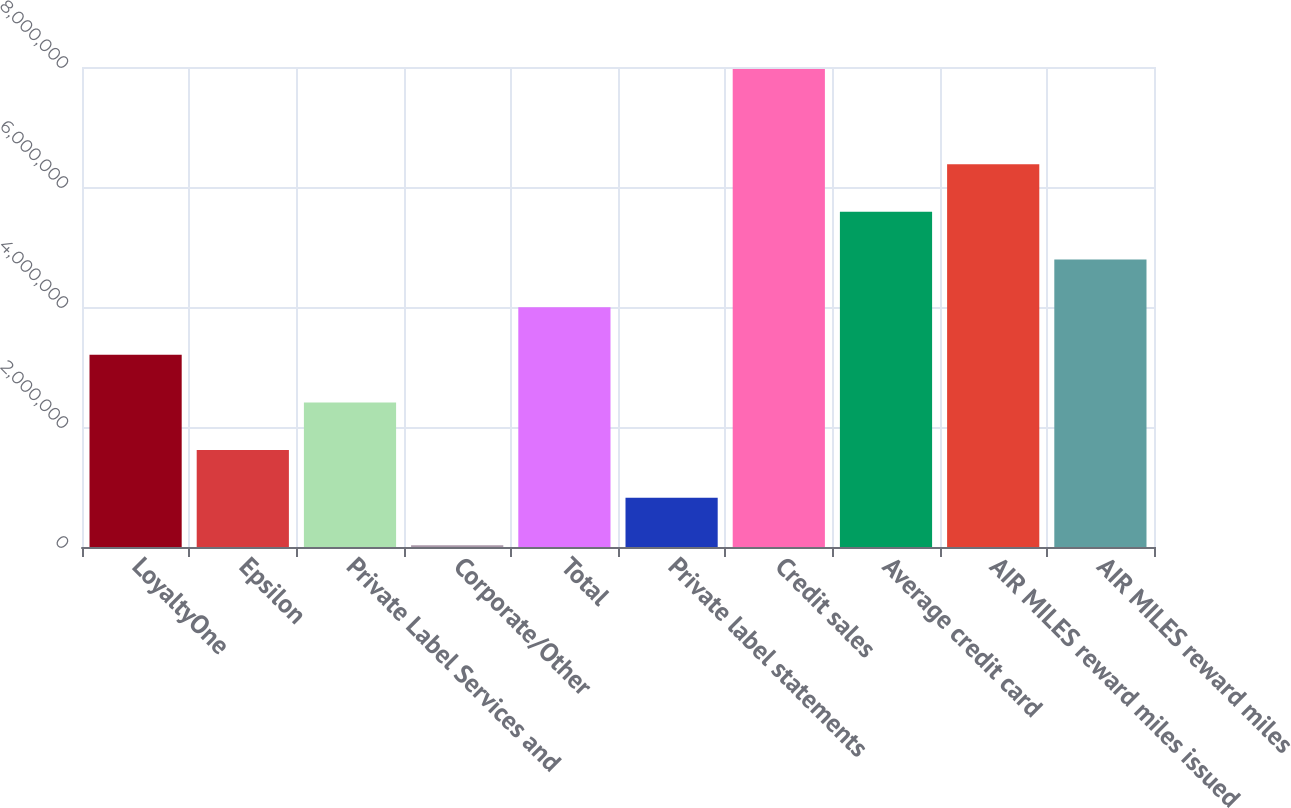Convert chart. <chart><loc_0><loc_0><loc_500><loc_500><bar_chart><fcel>LoyaltyOne<fcel>Epsilon<fcel>Private Label Services and<fcel>Corporate/Other<fcel>Total<fcel>Private label statements<fcel>Credit sales<fcel>Average credit card<fcel>AIR MILES reward miles issued<fcel>AIR MILES reward miles<nl><fcel>3.20368e+06<fcel>1.61553e+06<fcel>2.40961e+06<fcel>27385<fcel>3.99776e+06<fcel>821459<fcel>7.96812e+06<fcel>5.5859e+06<fcel>6.37998e+06<fcel>4.79183e+06<nl></chart> 